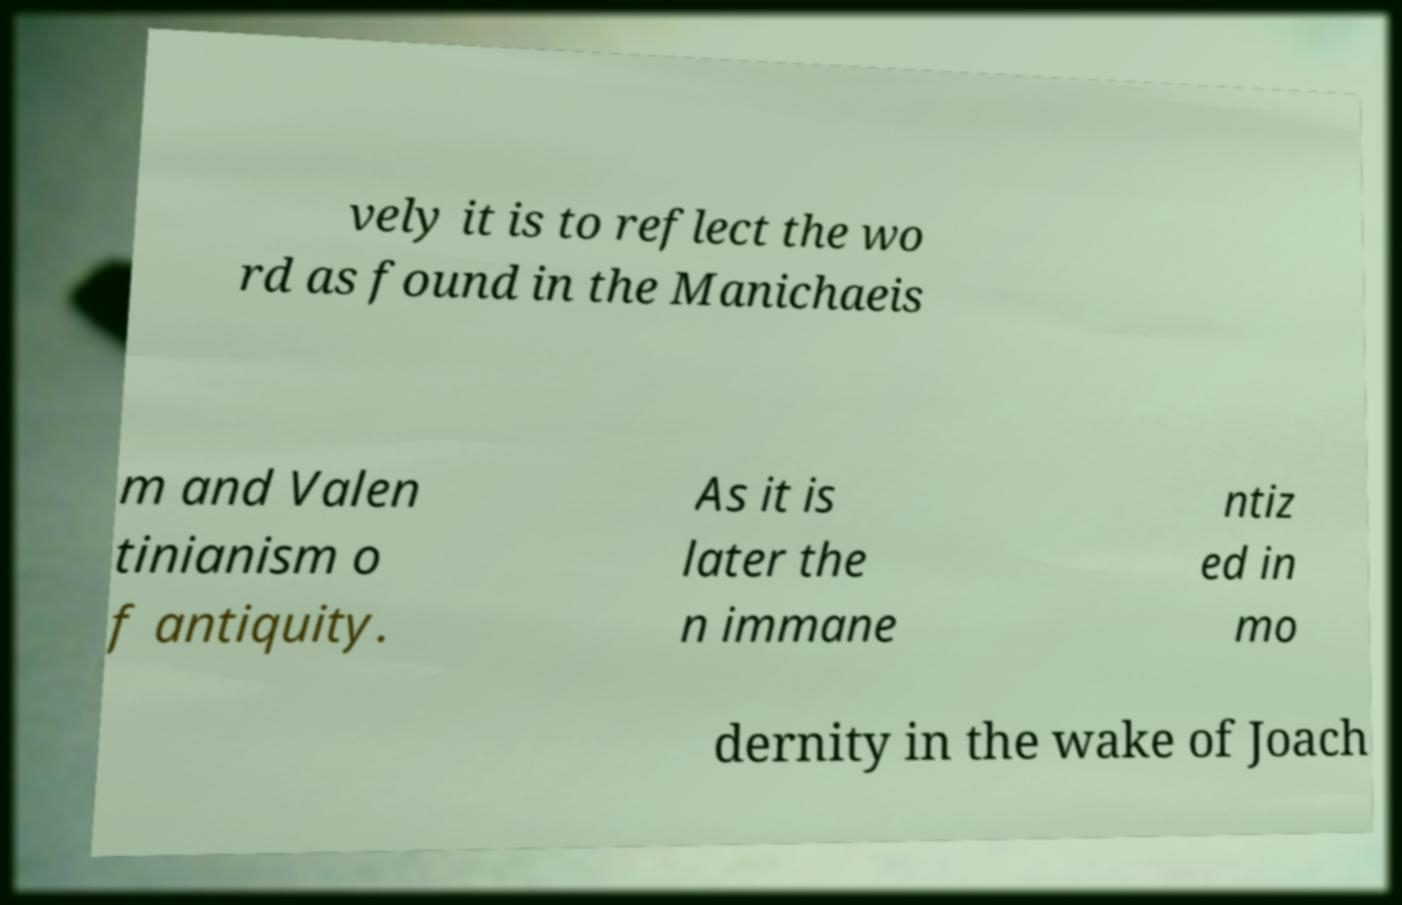Please identify and transcribe the text found in this image. vely it is to reflect the wo rd as found in the Manichaeis m and Valen tinianism o f antiquity. As it is later the n immane ntiz ed in mo dernity in the wake of Joach 